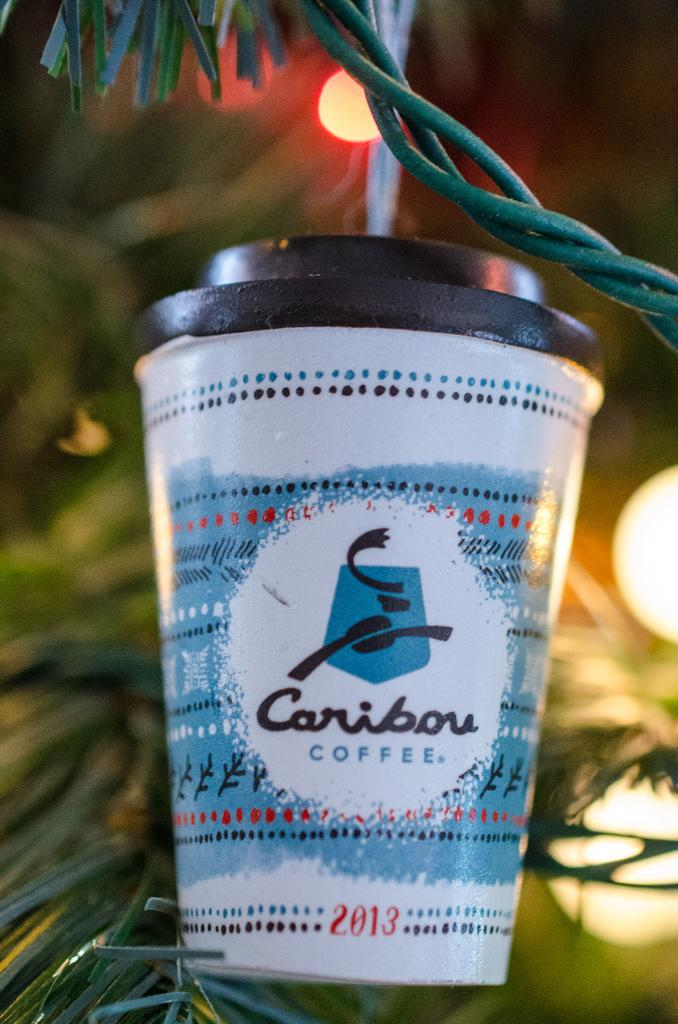<image>
Relay a brief, clear account of the picture shown. A Caribou Coffee ornament hangs from a Christmas tree. 